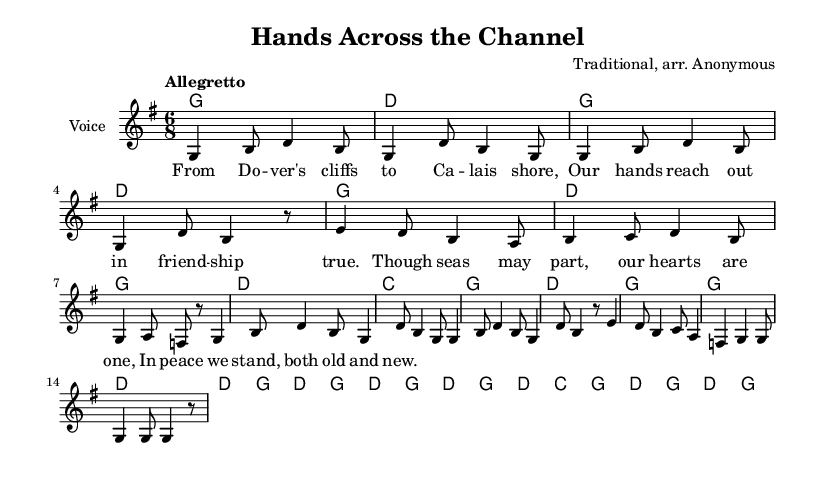What is the key signature of this music? The key signature is G major, indicated by one sharp in the notation.
Answer: G major What is the time signature of this piece? The time signature is 6/8, which is shown at the beginning of the score.
Answer: 6/8 What is the tempo marking for the piece? The tempo marking is "Allegretto," which suggests a moderately quick pace.
Answer: Allegretto How many measures are there in the melody? By counting the individual measures marked in the melody line, there are 12 measures in total.
Answer: 12 What is the first note of the melody? The first note of the melody is G, as indicated at the beginning of the melodic line.
Answer: G What is the harmonic progression used in the first phrase? The first phrase utilizes the harmonies G and D, following a pattern that establishes the tonality.
Answer: G and D What lyrical theme is represented in this folk song? The lyrics reflect themes of friendship and unity despite physical separation, emphasizing cultural connection.
Answer: Friendship and unity 